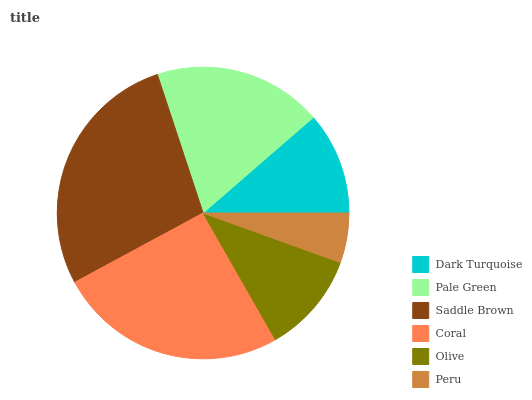Is Peru the minimum?
Answer yes or no. Yes. Is Saddle Brown the maximum?
Answer yes or no. Yes. Is Pale Green the minimum?
Answer yes or no. No. Is Pale Green the maximum?
Answer yes or no. No. Is Pale Green greater than Dark Turquoise?
Answer yes or no. Yes. Is Dark Turquoise less than Pale Green?
Answer yes or no. Yes. Is Dark Turquoise greater than Pale Green?
Answer yes or no. No. Is Pale Green less than Dark Turquoise?
Answer yes or no. No. Is Pale Green the high median?
Answer yes or no. Yes. Is Dark Turquoise the low median?
Answer yes or no. Yes. Is Peru the high median?
Answer yes or no. No. Is Olive the low median?
Answer yes or no. No. 